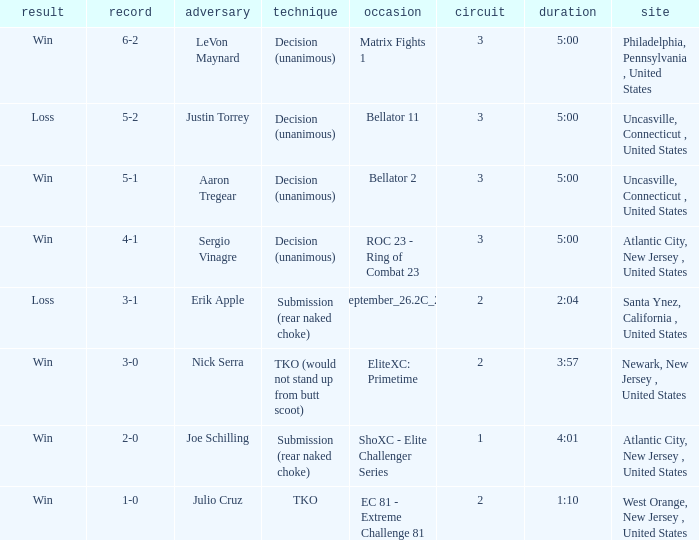What was the round that Sergio Vinagre had a time of 5:00? 3.0. 